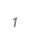<code> <loc_0><loc_0><loc_500><loc_500><_SQL_>

</code> 